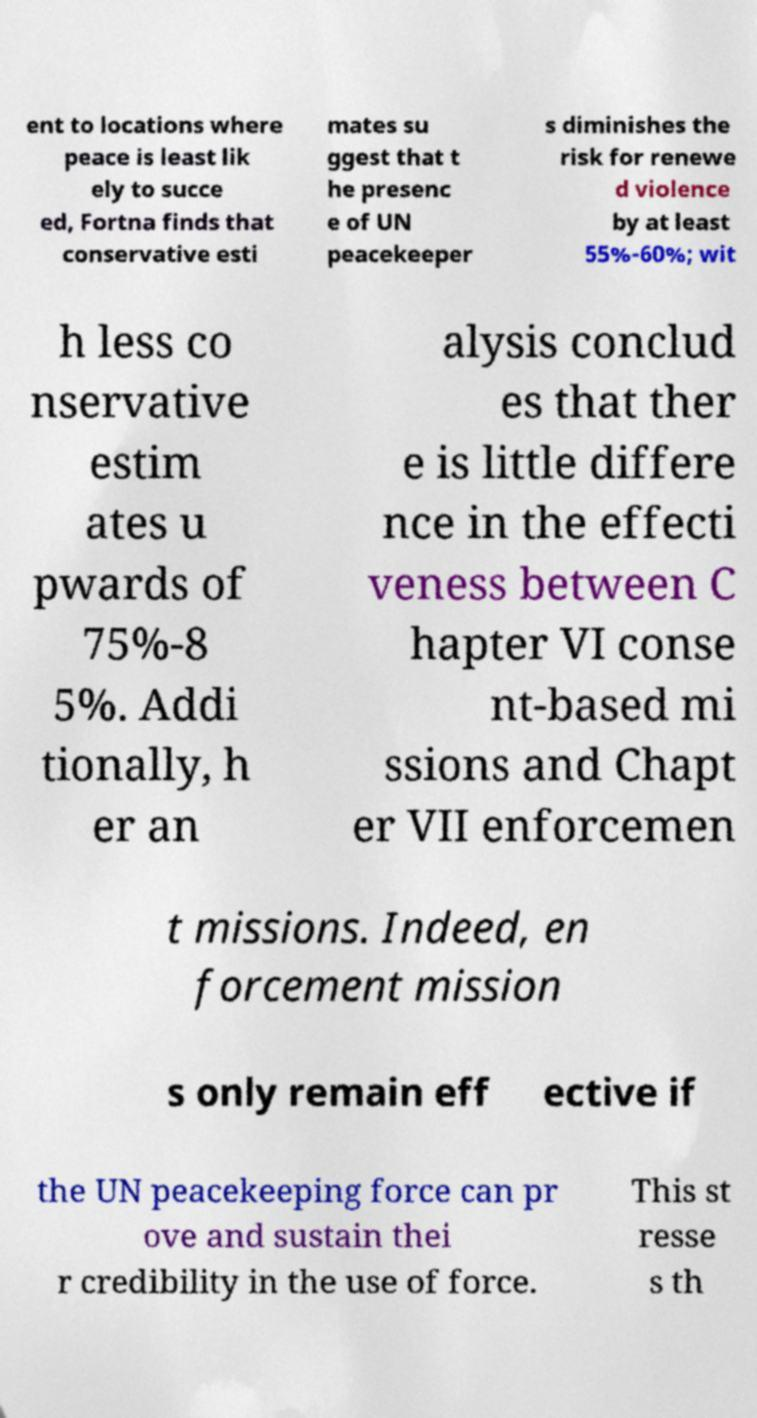Could you assist in decoding the text presented in this image and type it out clearly? ent to locations where peace is least lik ely to succe ed, Fortna finds that conservative esti mates su ggest that t he presenc e of UN peacekeeper s diminishes the risk for renewe d violence by at least 55%-60%; wit h less co nservative estim ates u pwards of 75%-8 5%. Addi tionally, h er an alysis conclud es that ther e is little differe nce in the effecti veness between C hapter VI conse nt-based mi ssions and Chapt er VII enforcemen t missions. Indeed, en forcement mission s only remain eff ective if the UN peacekeeping force can pr ove and sustain thei r credibility in the use of force. This st resse s th 